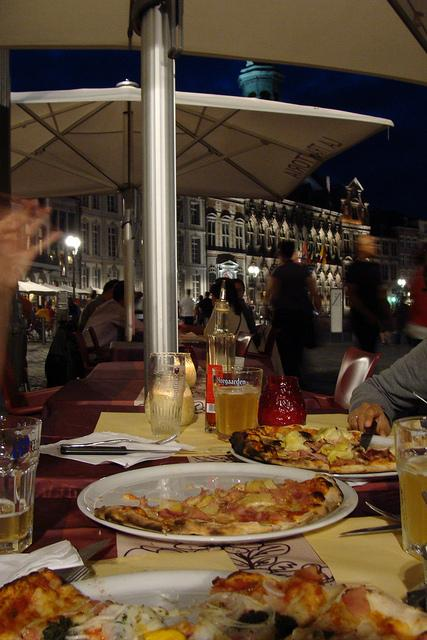What is this place?

Choices:
A) waste disposal
B) picnic
C) outdoor restaurant
D) farmers market outdoor restaurant 